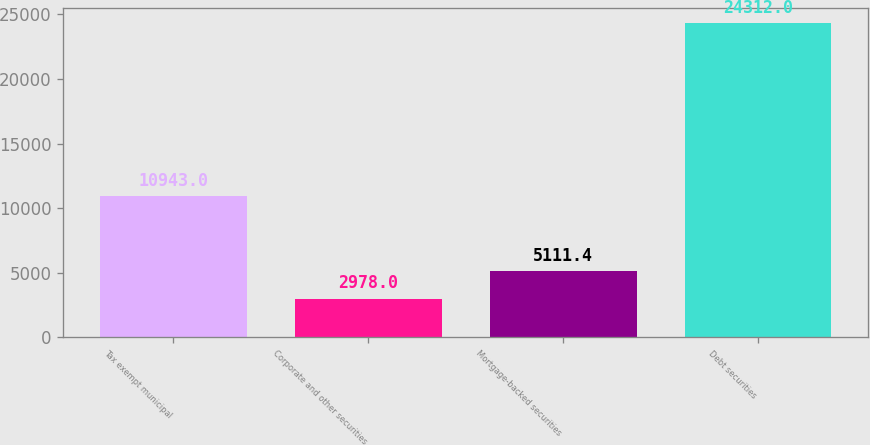Convert chart. <chart><loc_0><loc_0><loc_500><loc_500><bar_chart><fcel>Tax exempt municipal<fcel>Corporate and other securities<fcel>Mortgage-backed securities<fcel>Debt securities<nl><fcel>10943<fcel>2978<fcel>5111.4<fcel>24312<nl></chart> 